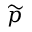Convert formula to latex. <formula><loc_0><loc_0><loc_500><loc_500>\widetilde { p }</formula> 